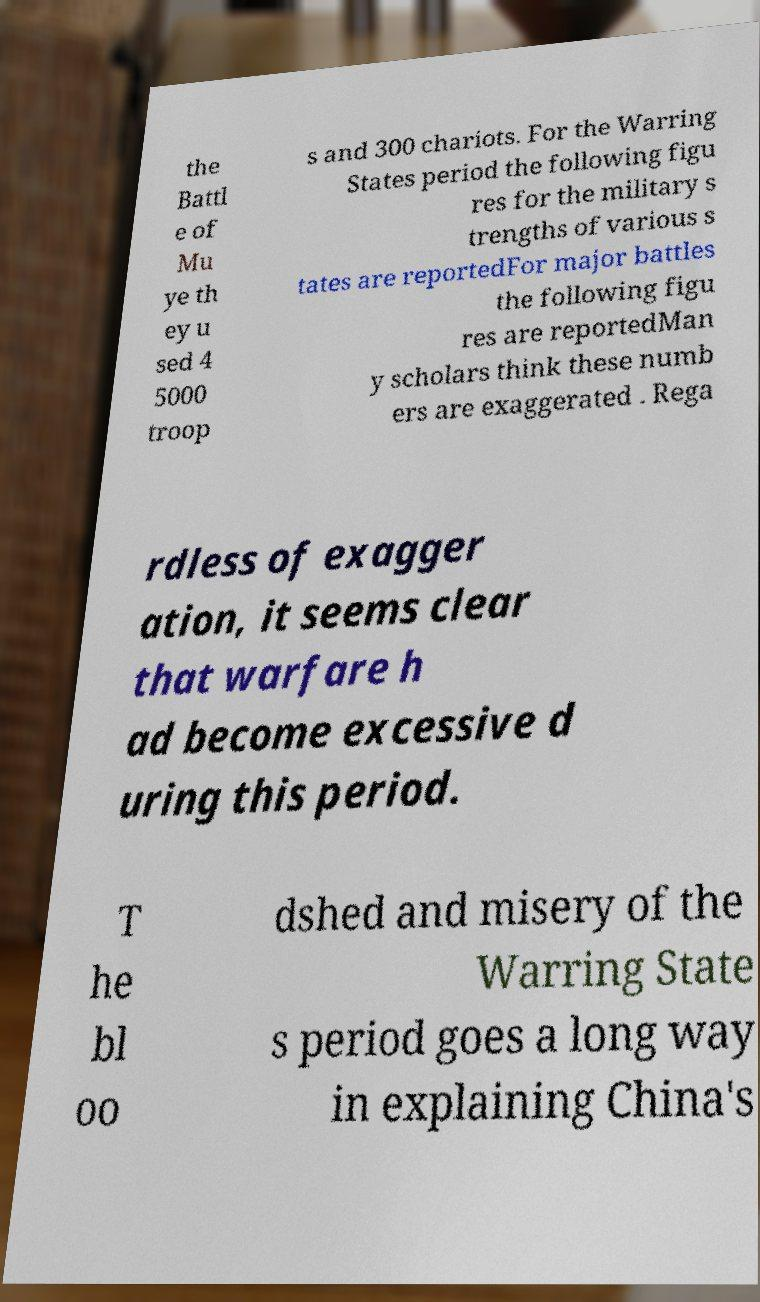I need the written content from this picture converted into text. Can you do that? the Battl e of Mu ye th ey u sed 4 5000 troop s and 300 chariots. For the Warring States period the following figu res for the military s trengths of various s tates are reportedFor major battles the following figu res are reportedMan y scholars think these numb ers are exaggerated . Rega rdless of exagger ation, it seems clear that warfare h ad become excessive d uring this period. T he bl oo dshed and misery of the Warring State s period goes a long way in explaining China's 